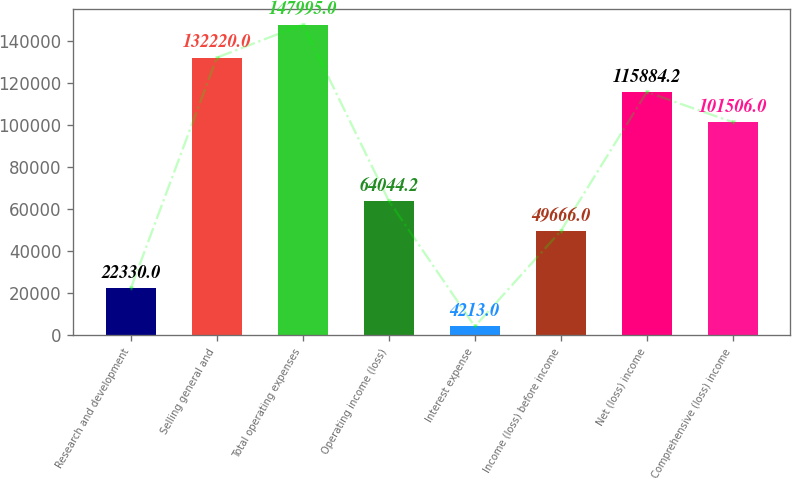Convert chart to OTSL. <chart><loc_0><loc_0><loc_500><loc_500><bar_chart><fcel>Research and development<fcel>Selling general and<fcel>Total operating expenses<fcel>Operating income (loss)<fcel>Interest expense<fcel>Income (loss) before income<fcel>Net (loss) income<fcel>Comprehensive (loss) income<nl><fcel>22330<fcel>132220<fcel>147995<fcel>64044.2<fcel>4213<fcel>49666<fcel>115884<fcel>101506<nl></chart> 